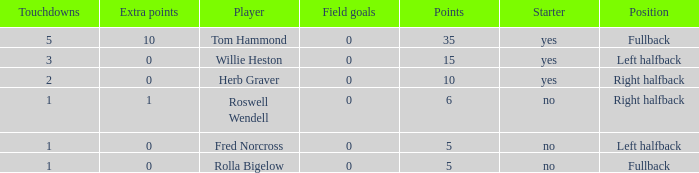What is the lowest number of touchdowns for left halfback WIllie Heston who has more than 15 points? None. 